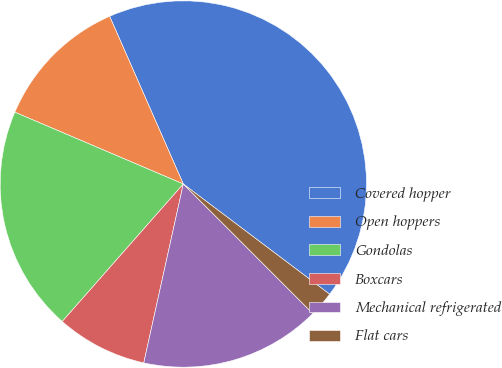<chart> <loc_0><loc_0><loc_500><loc_500><pie_chart><fcel>Covered hopper<fcel>Open hoppers<fcel>Gondolas<fcel>Boxcars<fcel>Mechanical refrigerated<fcel>Flat cars<nl><fcel>41.86%<fcel>12.0%<fcel>19.92%<fcel>8.03%<fcel>15.96%<fcel>2.23%<nl></chart> 